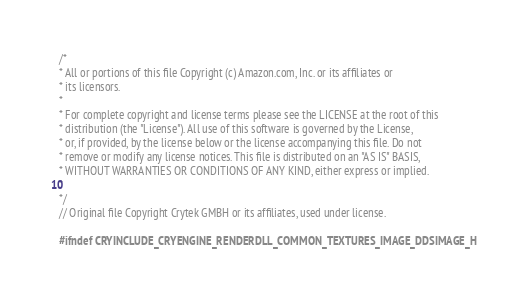<code> <loc_0><loc_0><loc_500><loc_500><_C_>/*
* All or portions of this file Copyright (c) Amazon.com, Inc. or its affiliates or
* its licensors.
*
* For complete copyright and license terms please see the LICENSE at the root of this
* distribution (the "License"). All use of this software is governed by the License,
* or, if provided, by the license below or the license accompanying this file. Do not
* remove or modify any license notices. This file is distributed on an "AS IS" BASIS,
* WITHOUT WARRANTIES OR CONDITIONS OF ANY KIND, either express or implied.
*
*/
// Original file Copyright Crytek GMBH or its affiliates, used under license.

#ifndef CRYINCLUDE_CRYENGINE_RENDERDLL_COMMON_TEXTURES_IMAGE_DDSIMAGE_H</code> 